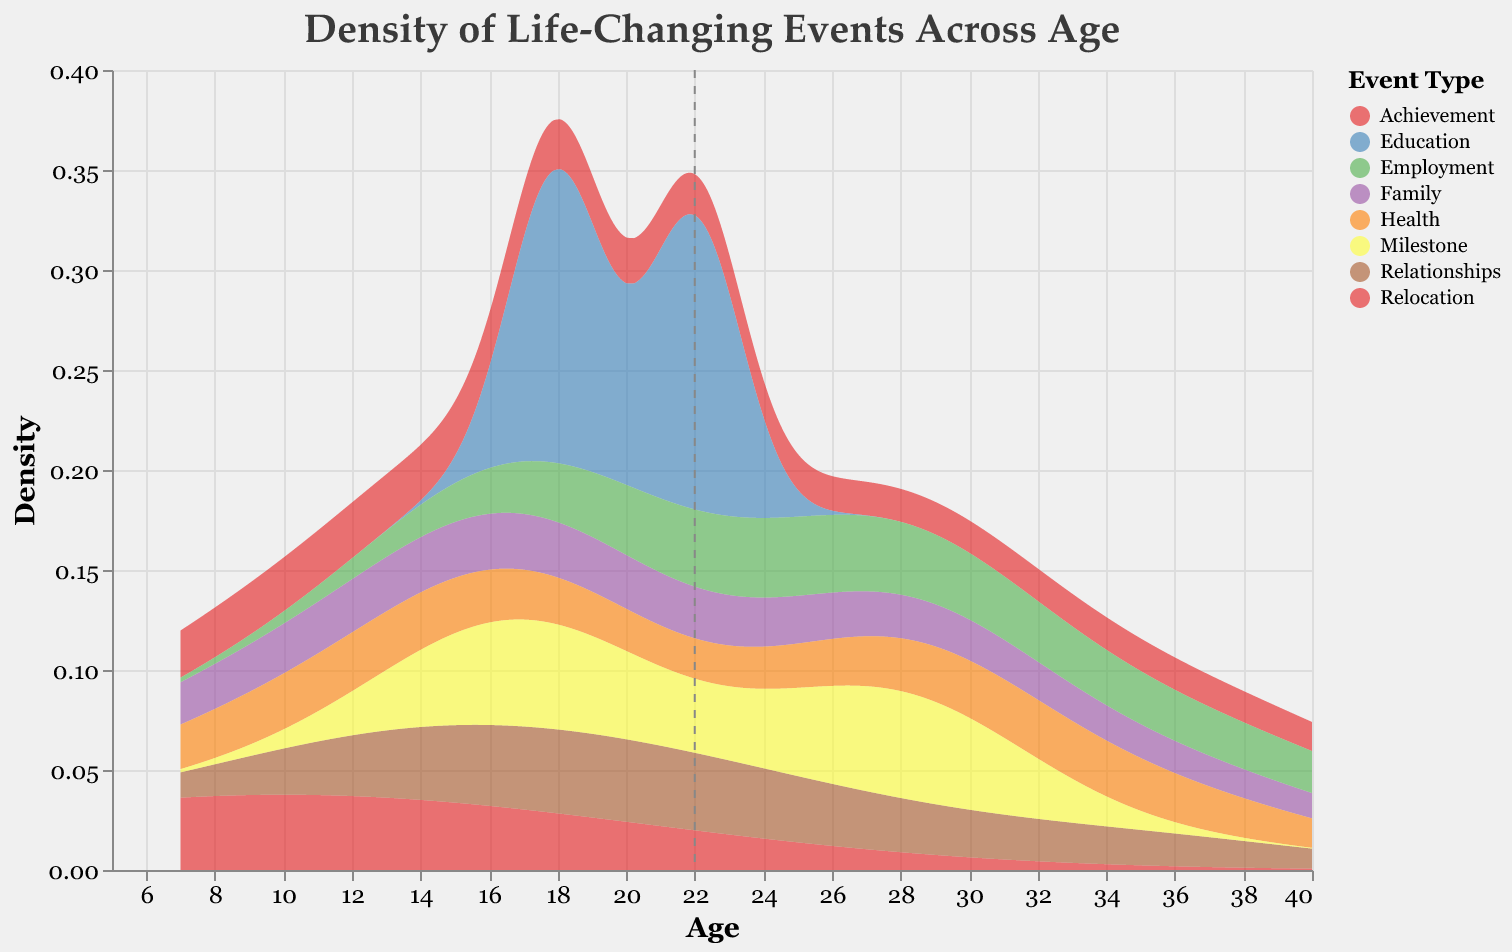What is the title of the plot? The title of the plot is displayed at the top of the figure and states, "Density of Life-Changing Events Across Age".
Answer: Density of Life-Changing Events Across Age What does the x-axis represent in the plot? The x-axis represents age, which is noted by the axis title "Age".
Answer: Age Which event type has the highest density at age 18? Look at the plot where age is 18 on the x-axis and identify which colored density curve reaches its peak at this point. The "Education" type peaks at age 18, which corresponds to "Starting University".
Answer: Education How many different event types are represented in the plot? The legend of the plot shows different colors representing different event types; count the different colors. There are seven types: Family, Achievement, Relocation, Health, Relationships, Milestone, and Employment.
Answer: 7 At what age does the density for "Employment" events peak? Identify the "Employment" type in the legend and follow its corresponding colored density curve. The "Employment" events have a peak around age 23, which corresponds to "Starting a Professional Career".
Answer: 23 Which event type has the broadest range of age distribution? Look at the spread of each colored density curve along the x-axis (age). "Relationships" have events ranging approximately from age 14 to 35, indicating a broad distribution.
Answer: Relationships At what age does the density for "Family" events drop significantly after an initial peak? Follow the "Family" density curve; it has an initial peak around ages 7-13 and then drops significantly after.
Answer: After 13 Compare the peak density of "Health" and "Milestone" events. Which one is higher? Locate the peaks of the "Health" and "Milestone" density curves and compare their heights on the y-axis. The "Health" events peak at age 12 and 32 are higher than the "Milestone" events peak around ages 17 and 28.
Answer: Health Are there any age ranges where only one type of event is dominant? Examine the density plot for any age ranges where only one density curve is apparant while others are close to zero. For instance, around age 37, "Achievement" (Starting Own Business) is the dominant event type.
Answer: Yes, around age 37 What is the average mean age across all event types? The rule showing a mean value for age indicates the average of all events. Locate the vertical dashed line crossing the x-axis which is around 21.
Answer: 21 